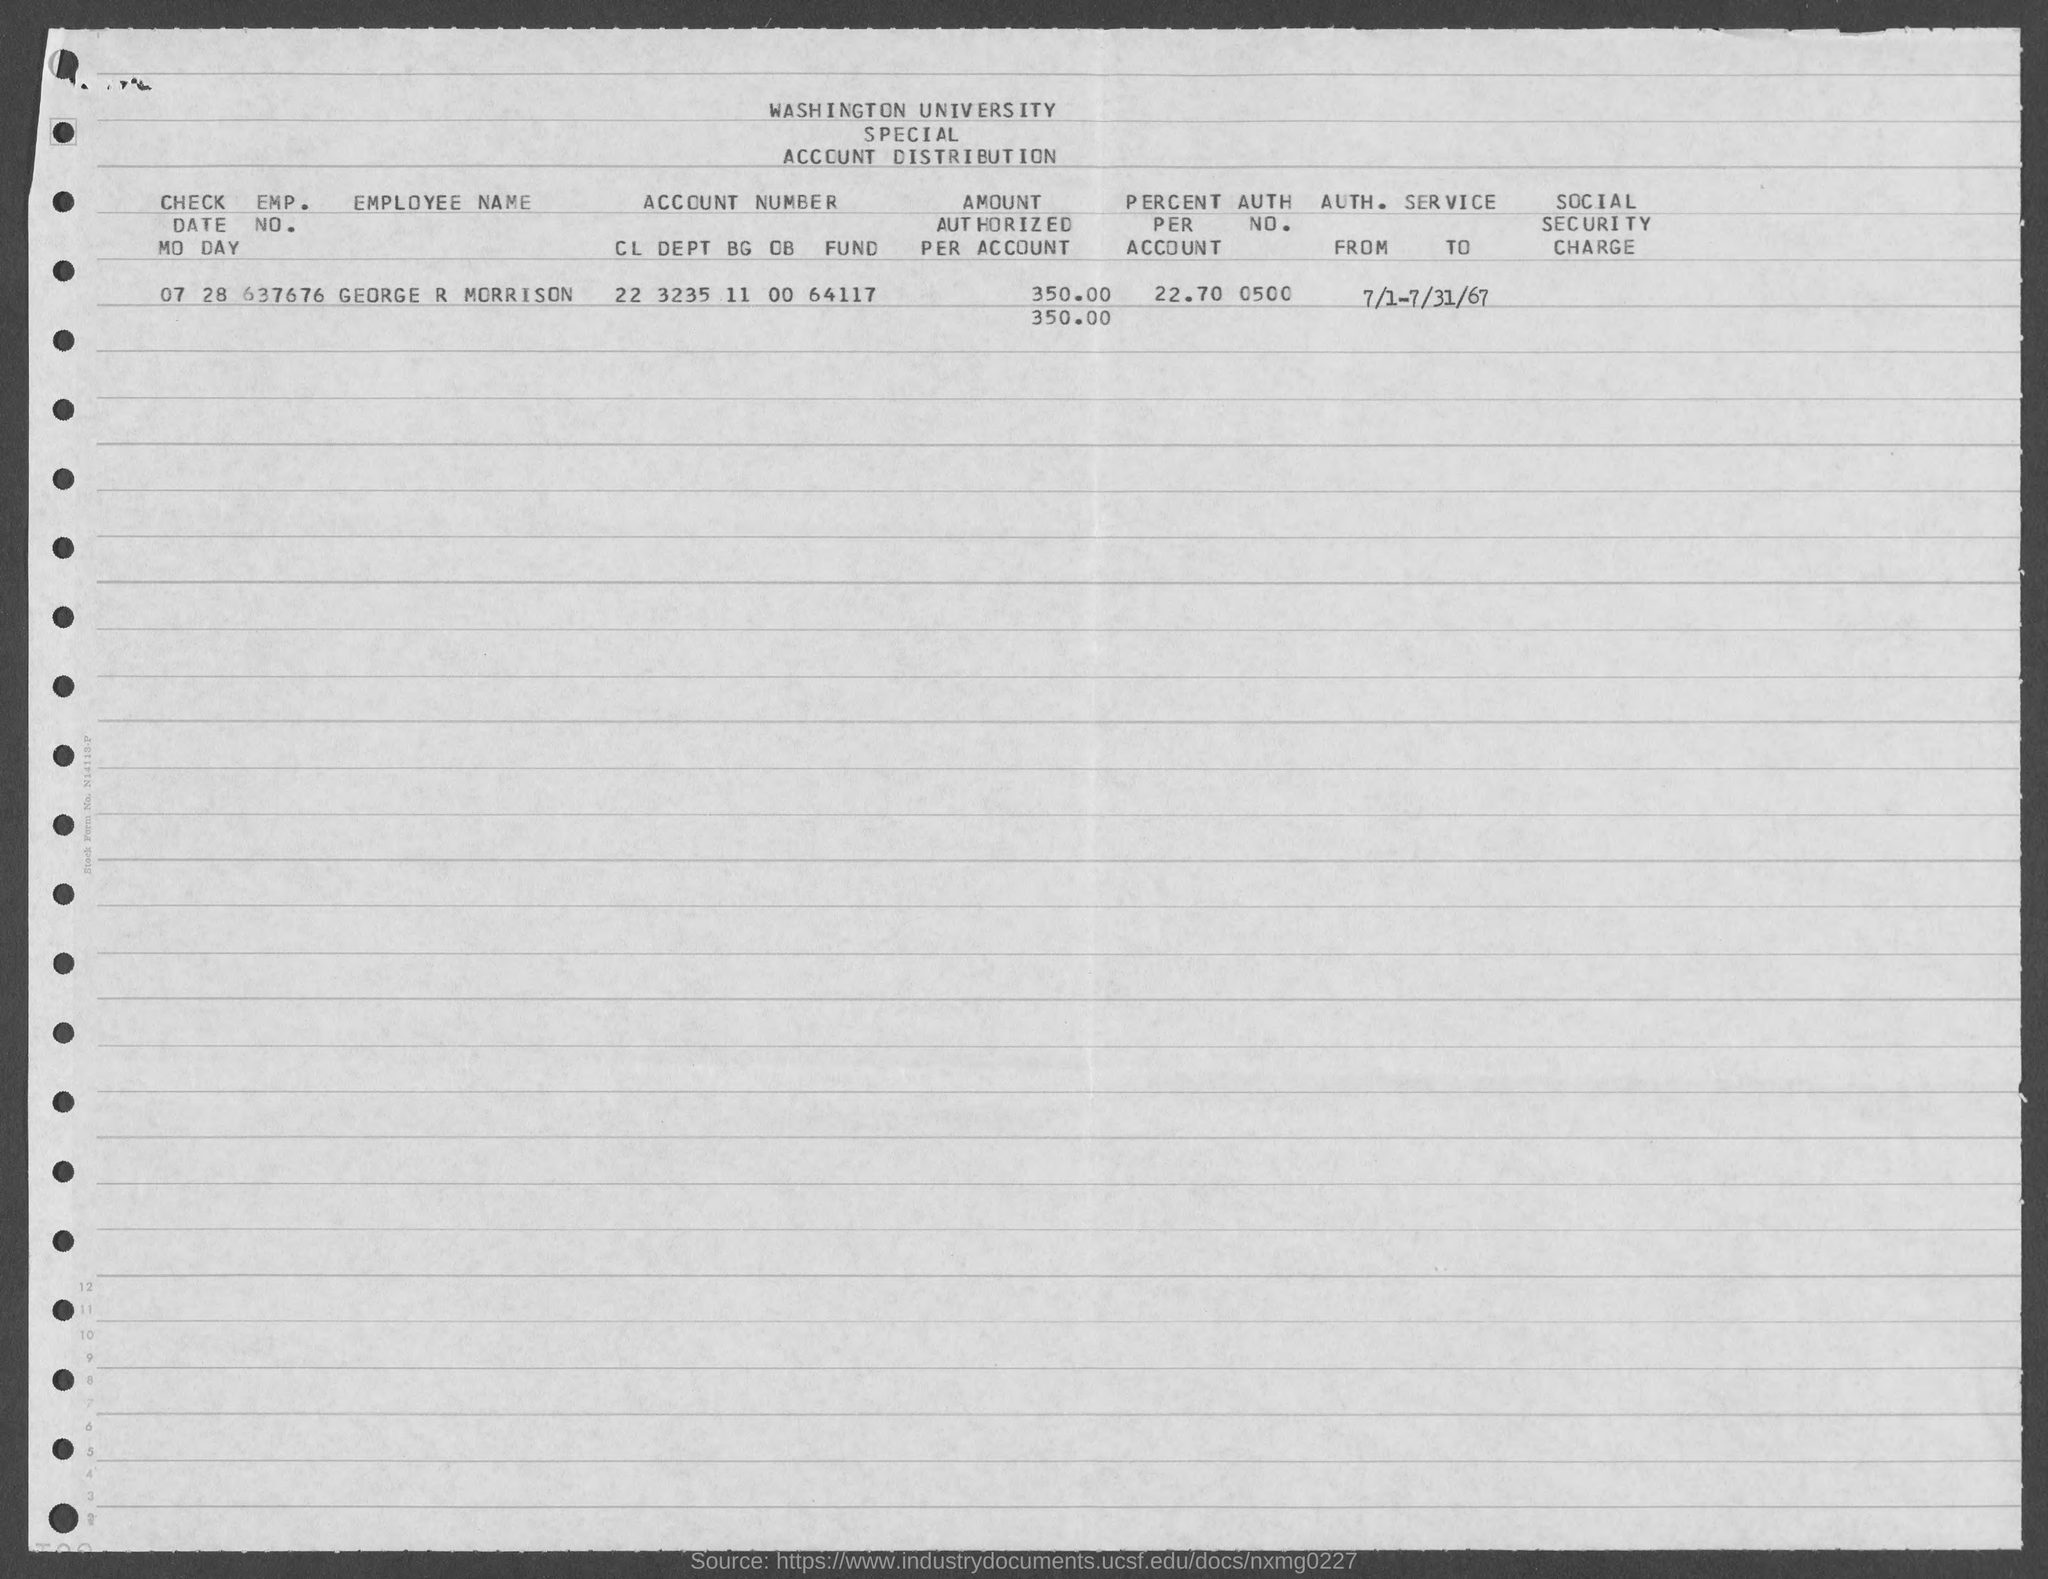Identify some key points in this picture. The emp. no. of George R Morrison is 637676... The authentication number mentioned in the given form is 0500.. The employee name mentioned in the given form is George R Morrison. What is the check date mentioned in the given form? The check date is 07/28... The value of the percentage as mentioned in the given form is 22.70%. 